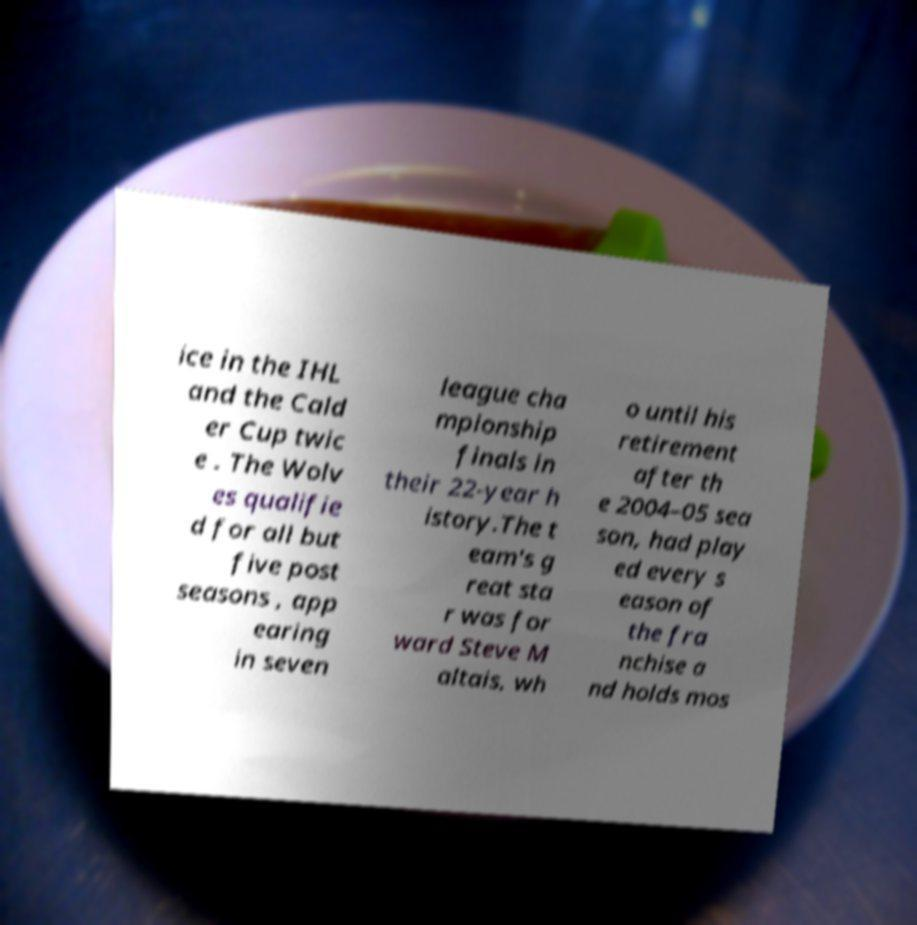Please identify and transcribe the text found in this image. ice in the IHL and the Cald er Cup twic e . The Wolv es qualifie d for all but five post seasons , app earing in seven league cha mpionship finals in their 22-year h istory.The t eam's g reat sta r was for ward Steve M altais, wh o until his retirement after th e 2004–05 sea son, had play ed every s eason of the fra nchise a nd holds mos 